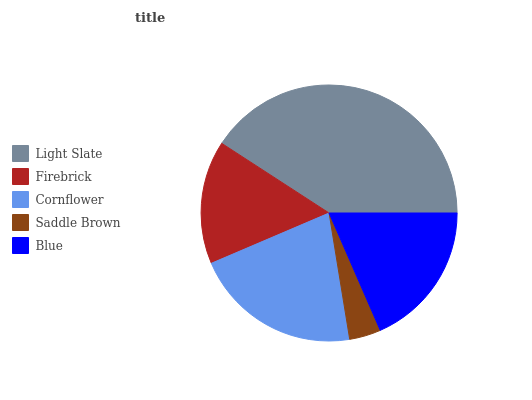Is Saddle Brown the minimum?
Answer yes or no. Yes. Is Light Slate the maximum?
Answer yes or no. Yes. Is Firebrick the minimum?
Answer yes or no. No. Is Firebrick the maximum?
Answer yes or no. No. Is Light Slate greater than Firebrick?
Answer yes or no. Yes. Is Firebrick less than Light Slate?
Answer yes or no. Yes. Is Firebrick greater than Light Slate?
Answer yes or no. No. Is Light Slate less than Firebrick?
Answer yes or no. No. Is Blue the high median?
Answer yes or no. Yes. Is Blue the low median?
Answer yes or no. Yes. Is Firebrick the high median?
Answer yes or no. No. Is Light Slate the low median?
Answer yes or no. No. 